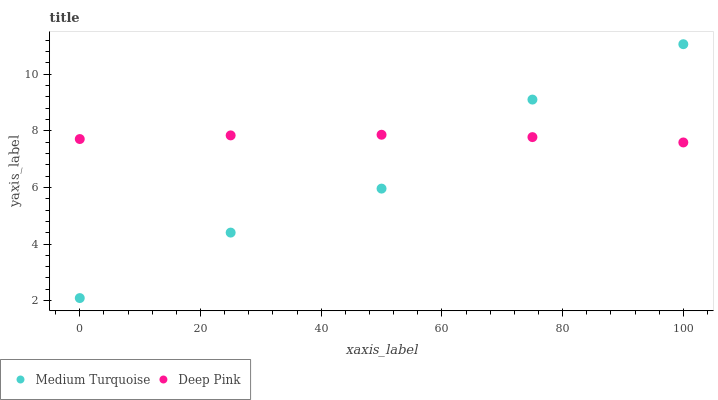Does Medium Turquoise have the minimum area under the curve?
Answer yes or no. Yes. Does Deep Pink have the maximum area under the curve?
Answer yes or no. Yes. Does Medium Turquoise have the maximum area under the curve?
Answer yes or no. No. Is Deep Pink the smoothest?
Answer yes or no. Yes. Is Medium Turquoise the roughest?
Answer yes or no. Yes. Is Medium Turquoise the smoothest?
Answer yes or no. No. Does Medium Turquoise have the lowest value?
Answer yes or no. Yes. Does Medium Turquoise have the highest value?
Answer yes or no. Yes. Does Medium Turquoise intersect Deep Pink?
Answer yes or no. Yes. Is Medium Turquoise less than Deep Pink?
Answer yes or no. No. Is Medium Turquoise greater than Deep Pink?
Answer yes or no. No. 